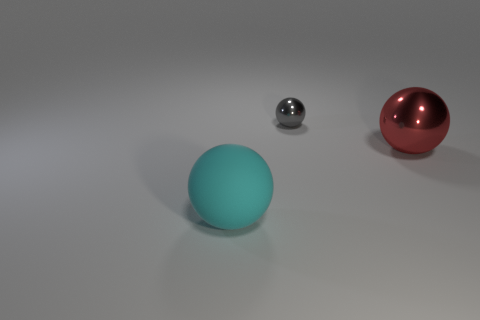Does the gray metal object have the same shape as the large object on the left side of the large red shiny thing?
Make the answer very short. Yes. How many objects are big spheres that are behind the cyan ball or big spheres behind the big cyan matte sphere?
Provide a short and direct response. 1. What is the material of the cyan ball?
Keep it short and to the point. Rubber. How many other things are the same size as the rubber object?
Ensure brevity in your answer.  1. There is a shiny thing in front of the small gray metallic thing; how big is it?
Provide a short and direct response. Large. What is the material of the large sphere that is to the right of the sphere in front of the metal thing that is in front of the small gray metal sphere?
Keep it short and to the point. Metal. Do the large cyan matte object and the gray object have the same shape?
Make the answer very short. Yes. How many shiny objects are either small balls or cyan objects?
Give a very brief answer. 1. How many gray balls are there?
Provide a short and direct response. 1. What is the color of the other object that is the same size as the cyan object?
Offer a terse response. Red. 